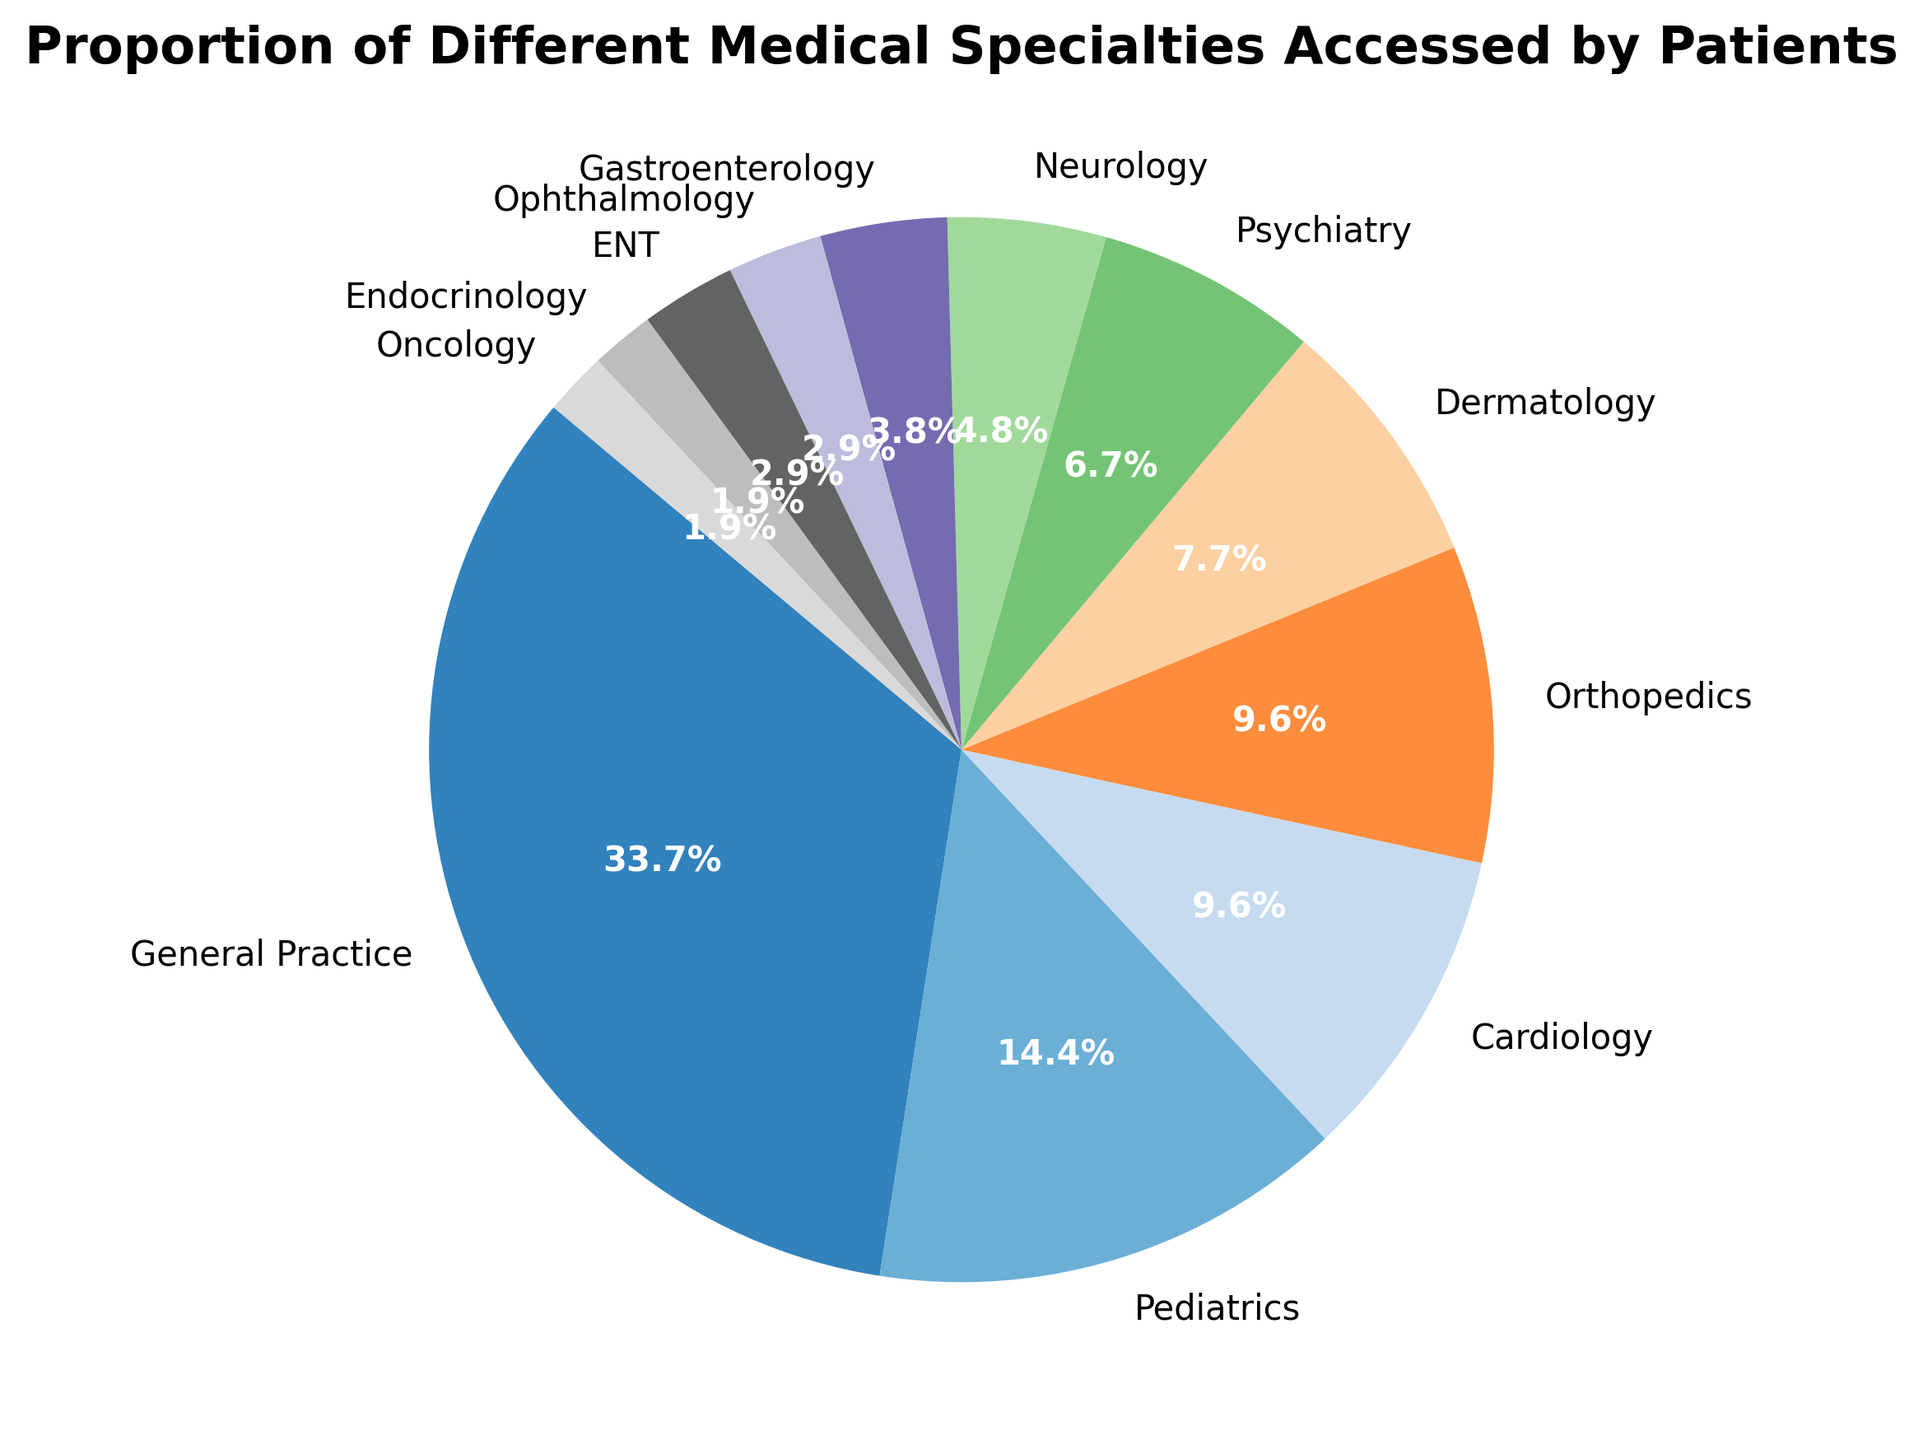What medical specialty has the highest proportion of patient visits? The pie chart shows that General Practice occupies the largest segment. This can be observed by comparing the sizes of each segment.
Answer: General Practice How many total specialties make up at least 0.10 of the proportion? We need to count the specialties with a proportion of 0.10 or higher: General Practice (0.35), Pediatrics (0.15), Cardiology (0.10), Orthopedics (0.10). There are four such specialties.
Answer: 4 What is the combined proportion of the Cardiology, Orthopedics, and Dermatology specialties? To find the combined proportion, add the proportions of these three specialties: Cardiology (0.10), Orthopedics (0.10), and Dermatology (0.08). The sum is 0.10 + 0.10 + 0.08 = 0.28
Answer: 0.28 Which two specialties have the smallest proportions and what is their cumulative proportion? The smallest proportions are from Endocrinology (0.02) and Oncology (0.02). To find their cumulative proportion, add them: 0.02 + 0.02 = 0.04.
Answer: 0.04 How does the proportion of Neurology compare to Psychiatry? By comparing the proportions from the chart, Neurology has a proportion of 0.05, while Psychiatry has a proportion of 0.07. Neurology is less than Psychiatry.
Answer: Neurology < Psychiatry What is the difference in proportions between General Practice and Pediatrics? The proportions for General Practice and Pediatrics are 0.35 and 0.15 respectively. The difference is 0.35 - 0.15 = 0.20.
Answer: 0.20 Which specialties have a combined proportion equal to the proportion of General Practice? By looking at the chart, Gastroenterology (0.04), Ophthalmology (0.03), ENT (0.03), Endocrinology (0.02), Oncology (0.02), Psychiatry (0.07), and Dermatology (0.08) combined: 0.04 + 0.03 + 0.03 + 0.02 + 0.02 + 0.07 + 0.08 = 0.29. No combinations add exactly to 0.35, so no specialties combine to equal General Practice’s proportion.
Answer: None Are there more specialties with a proportion greater than or equal to 0.10, or less than 0.10? Count the specialties: those with 0.10 or more are General Practice, Pediatrics, Cardiology, Orthopedics (4), and those with less than 0.10: Dermatology, Psychiatry, Neurology, Gastroenterology, Ophthalmology, ENT, Endocrinology, Oncology (8). There are more specialties with less than 0.10.
Answer: Less than 0.10 